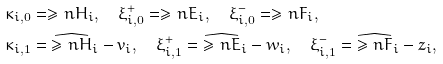<formula> <loc_0><loc_0><loc_500><loc_500>& \kappa _ { i , 0 } = \geq n { H } _ { i } , \quad \xi ^ { + } _ { i , 0 } = \geq n { E } _ { i } , \quad \xi ^ { - } _ { i , 0 } = \geq n { F } _ { i } , \\ & \kappa _ { i , 1 } = \widehat { \geq n { H } } _ { i } - v _ { i } , \quad \xi ^ { + } _ { i , 1 } = \widehat { \geq n { E } } _ { i } - w _ { i } , \quad \xi ^ { - } _ { i , 1 } = \widehat { \geq n { F } } _ { i } - z _ { i } ,</formula> 